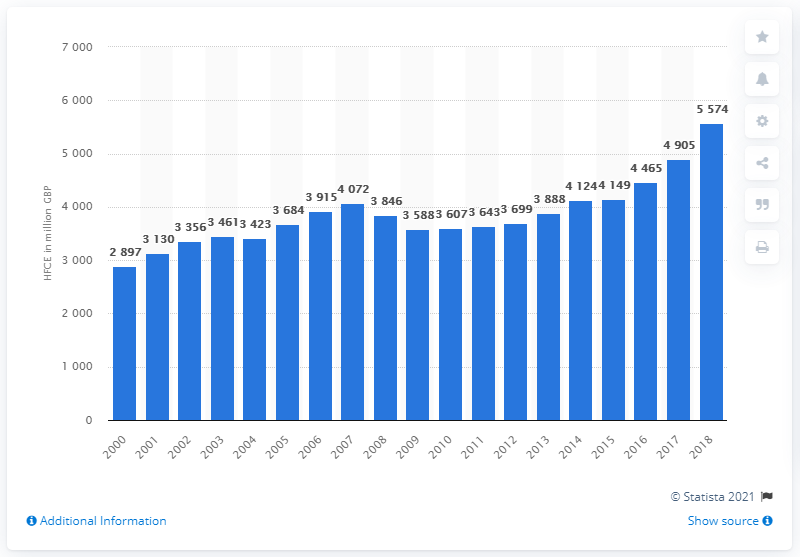List a handful of essential elements in this visual. In 2018, Scotland's expenditure on household goods and services was 5,574. 